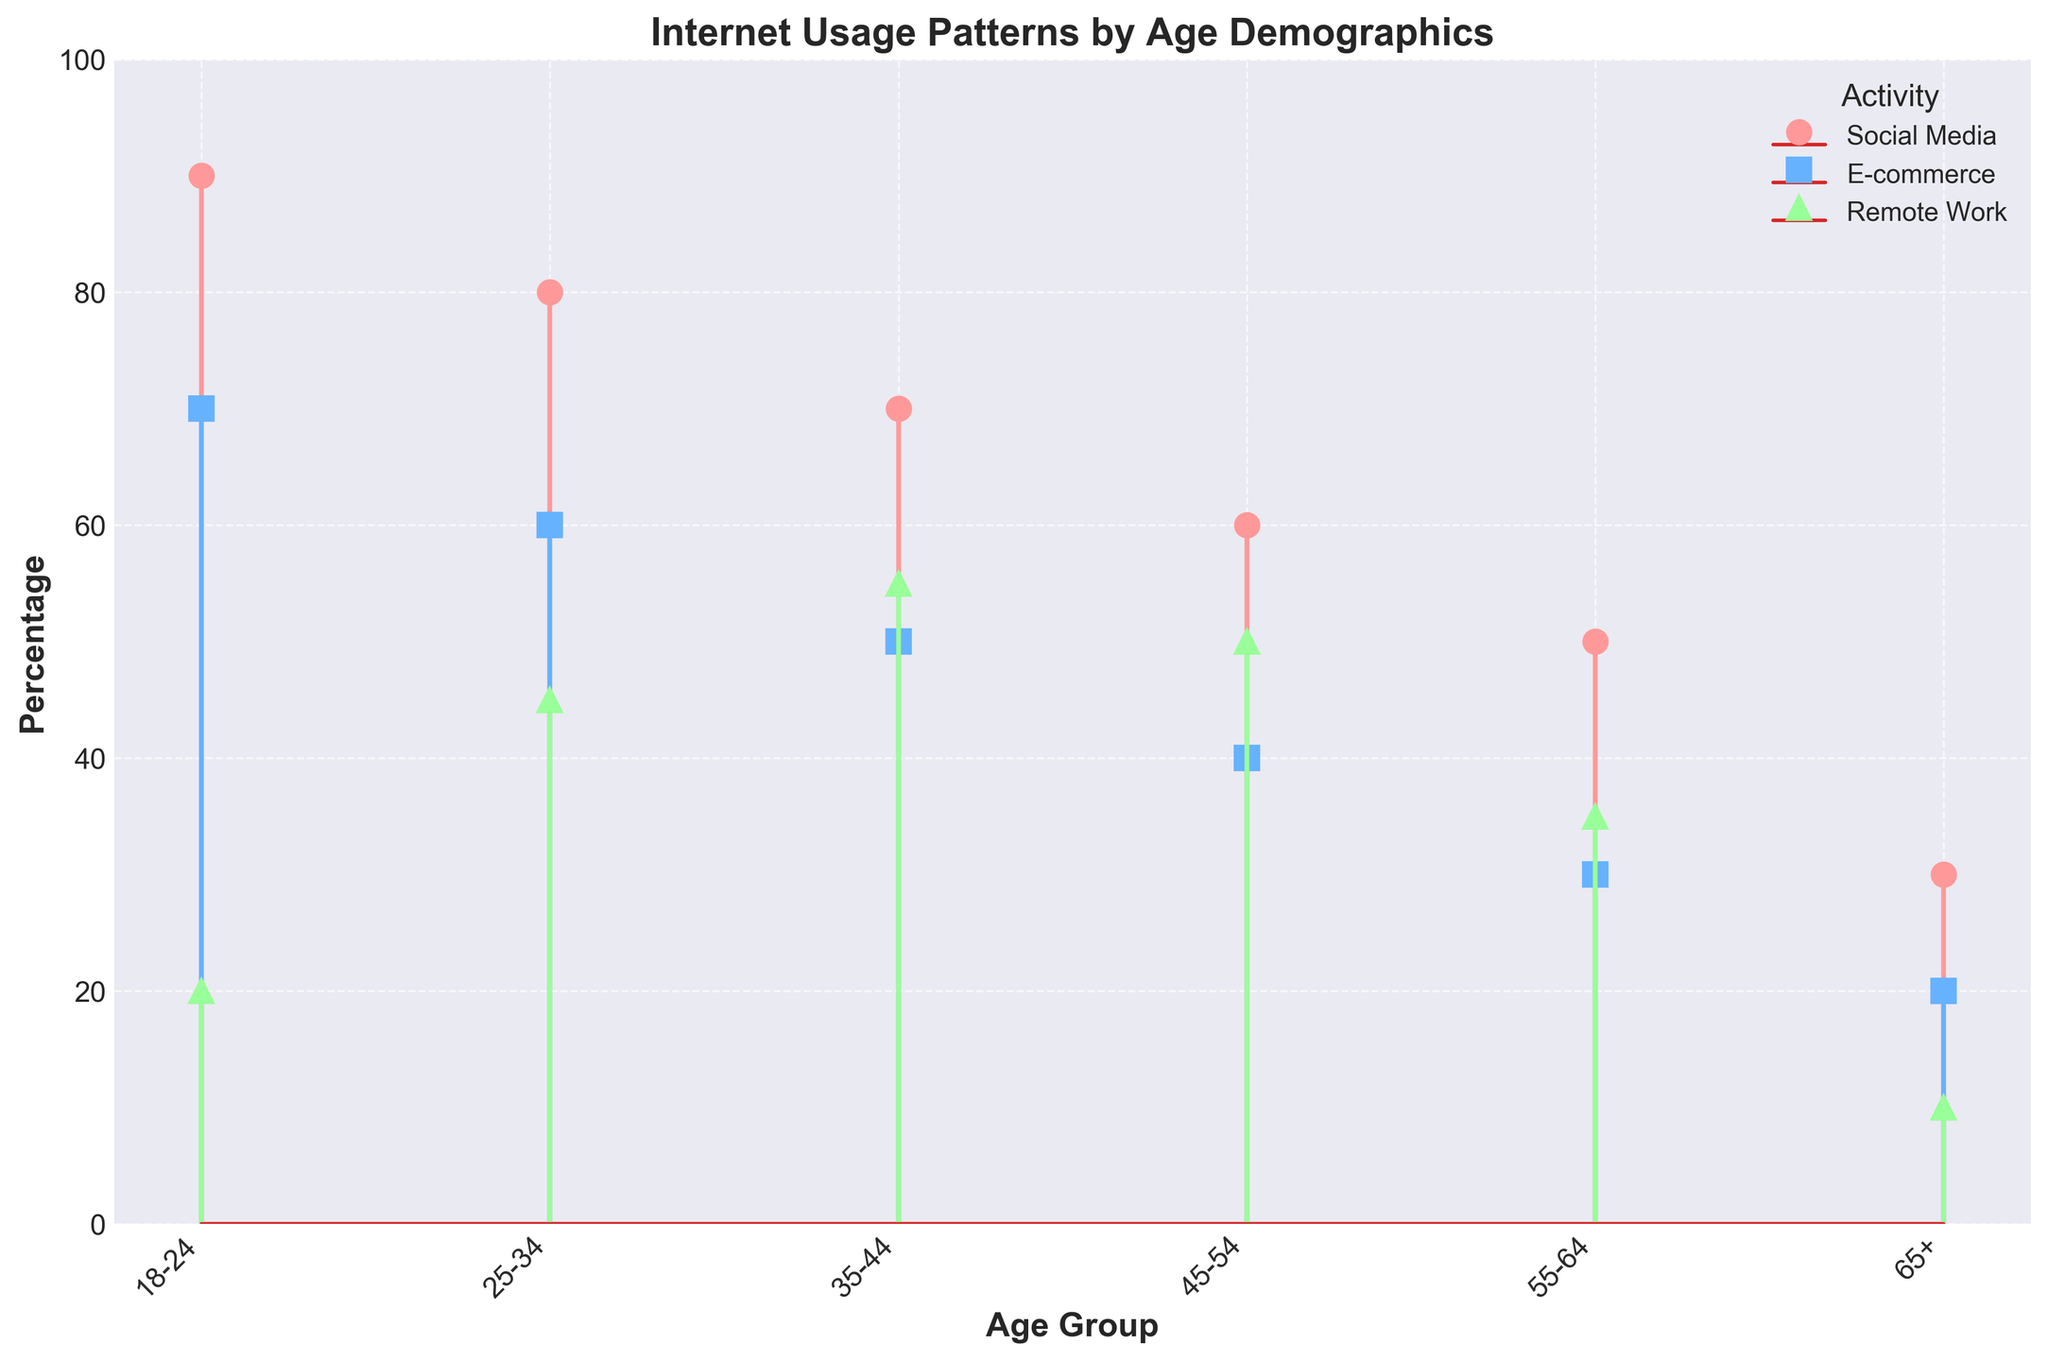What is the title of the figure? The title of the figure can be found at the top of the plot area.
Answer: Internet Usage Patterns by Age Demographics Which age group has the highest percentage of social media usage? Locate the stem with the highest value among the lines colored and marked for social media usage.
Answer: 18-24 What is the percentage difference in remote work usage between the age groups 25-34 and 35-44? Locate the remote work percentages for both age groups and subtract the lower percentage from the higher one: 55% - 45% = 10%.
Answer: 10% Which activity has the lowest overall percentage and in which age group? Compare the lowest percentages of all activities for each age group to find the minimum value. The lowest percentage is 10% for remote work in the 65+ age group.
Answer: Remote Work, 65+ Between which two consecutive age groups is the largest drop in social media usage observed? Find the differences in social media usage percentages between each consecutive age group and identify the largest drop: 50% (55-64) - 30% (65+) = 20%.
Answer: 55-64 and 65+ How does social media usage change as age groups increase? Observe the trend in the social media usage percentages from youngest to oldest age groups: the percentages decrease steadily as age increases.
Answer: Decreases Which age group engages most in e-commerce? Find the highest value in the e-commerce category and refer to the corresponding age group: 70% for the 18-24 age group.
Answer: 18-24 What is the average percentage of remote work usage across all age groups? Add the remote work percentages for all age groups and divide by the number of age groups: (20 + 45 + 55 + 50 + 35 + 10) / 6 ≈ 35.83%.
Answer: Approximately 35.83% Which activity shows the largest variation across age groups? Compare the range of percentages (highest value minus lowest value) for each activity: social media (90-30=60), e-commerce (70-20=50), remote work (55-10=45). The largest variation is in social media.
Answer: Social Media Is remote work more common in the 35-44 age group or the 45-54 age group? Compare the percentages of remote work for the two age groups: 35-44 (55%) and 45-54 (50%). 55% is higher.
Answer: 35-44 